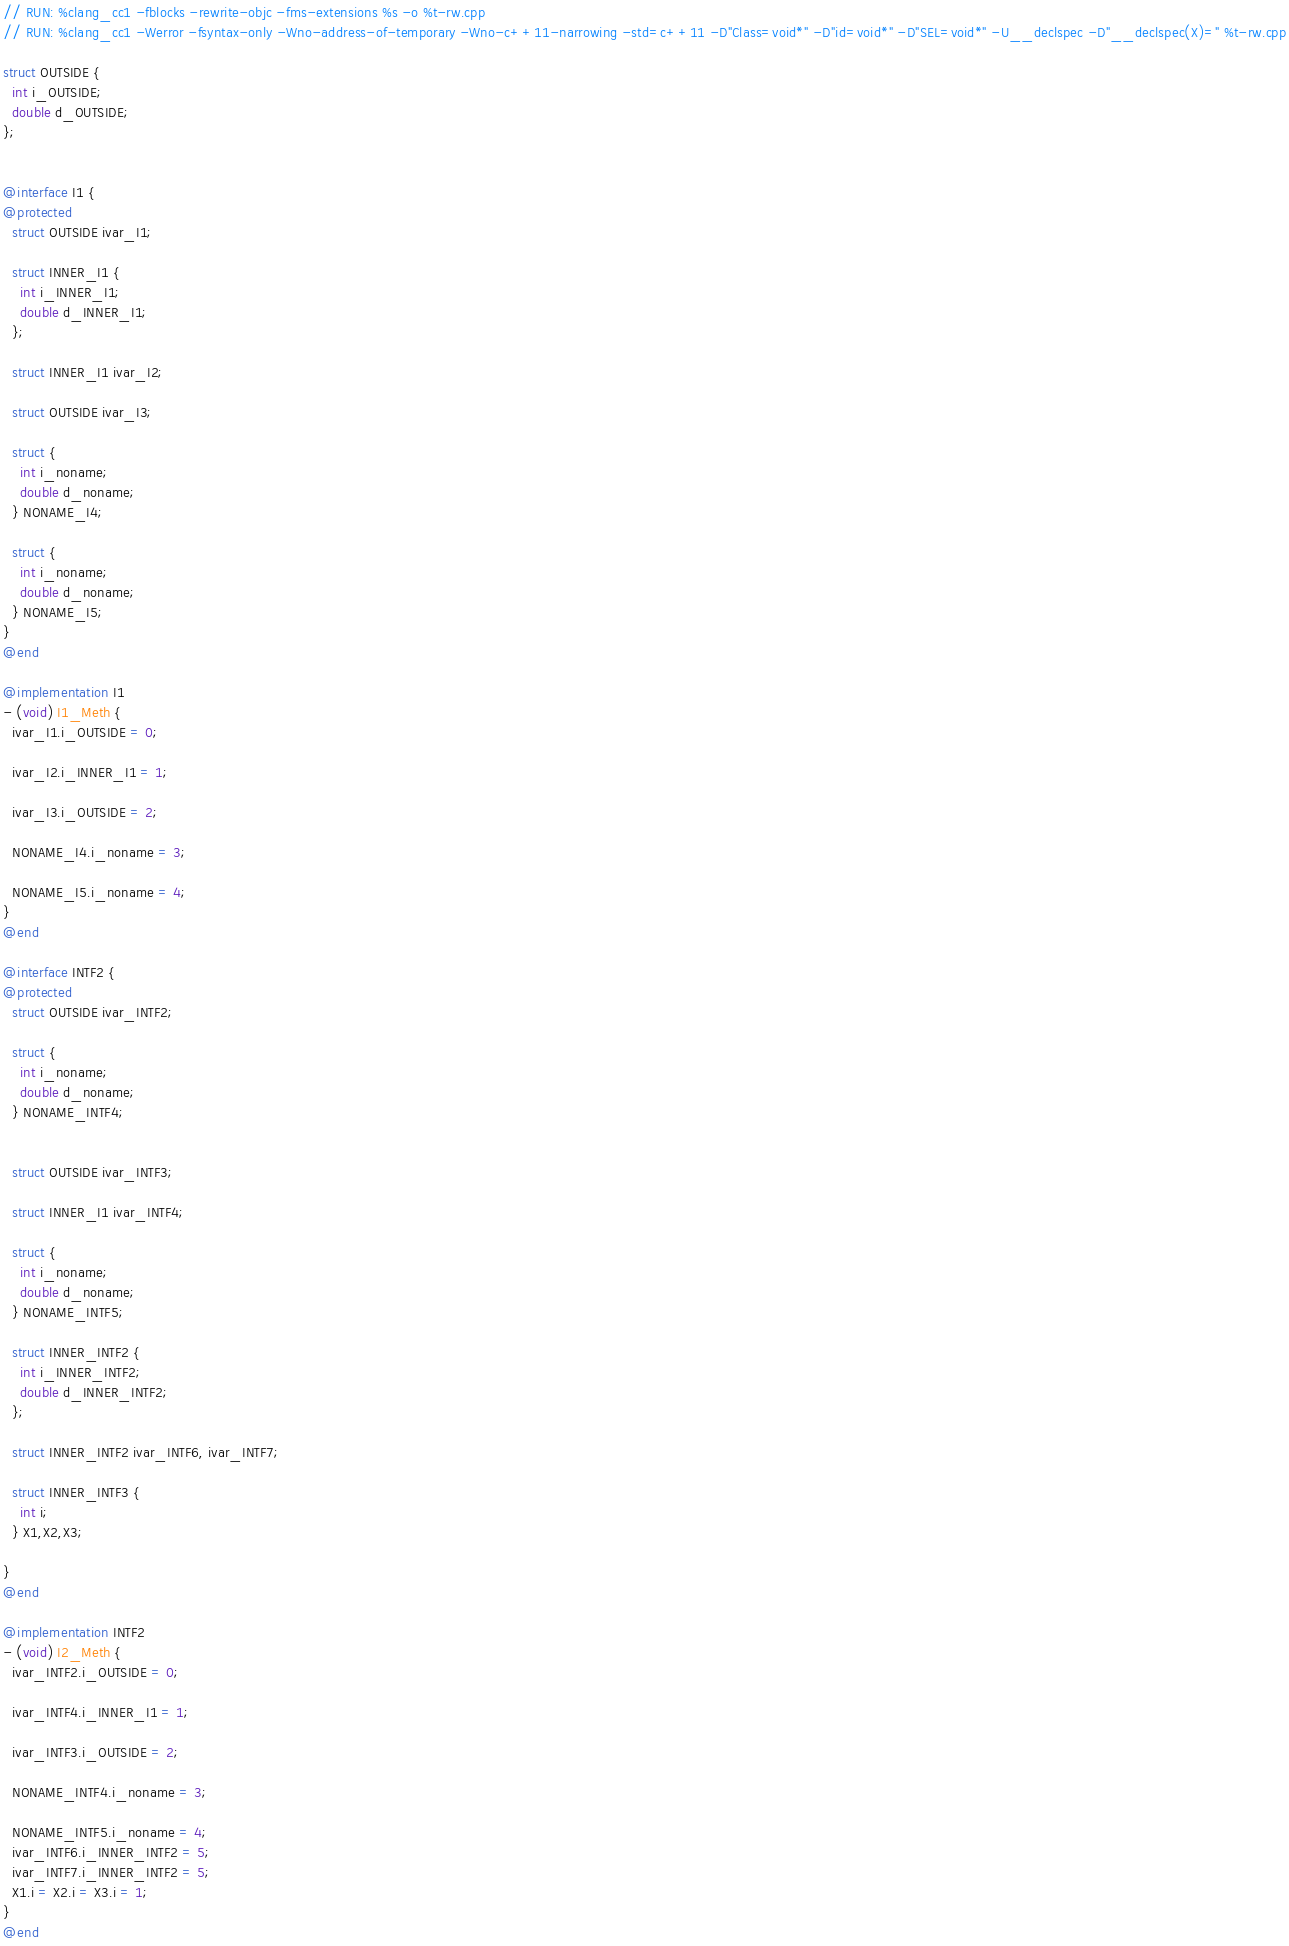Convert code to text. <code><loc_0><loc_0><loc_500><loc_500><_ObjectiveC_>// RUN: %clang_cc1 -fblocks -rewrite-objc -fms-extensions %s -o %t-rw.cpp
// RUN: %clang_cc1 -Werror -fsyntax-only -Wno-address-of-temporary -Wno-c++11-narrowing -std=c++11 -D"Class=void*" -D"id=void*" -D"SEL=void*" -U__declspec -D"__declspec(X)=" %t-rw.cpp

struct OUTSIDE {
  int i_OUTSIDE;
  double d_OUTSIDE;
};


@interface I1 {
@protected
  struct OUTSIDE ivar_I1;

  struct INNER_I1 {
    int i_INNER_I1;
    double d_INNER_I1;
  };

  struct INNER_I1 ivar_I2;

  struct OUTSIDE ivar_I3;

  struct {
    int i_noname;
    double d_noname;
  } NONAME_I4;

  struct {
    int i_noname;
    double d_noname;
  } NONAME_I5;
}
@end

@implementation I1
- (void) I1_Meth {
  ivar_I1.i_OUTSIDE = 0;

  ivar_I2.i_INNER_I1 = 1;

  ivar_I3.i_OUTSIDE = 2;

  NONAME_I4.i_noname = 3;

  NONAME_I5.i_noname = 4;
}
@end

@interface INTF2 {
@protected
  struct OUTSIDE ivar_INTF2;

  struct {
    int i_noname;
    double d_noname;
  } NONAME_INTF4;


  struct OUTSIDE ivar_INTF3;

  struct INNER_I1 ivar_INTF4;

  struct {
    int i_noname;
    double d_noname;
  } NONAME_INTF5;

  struct INNER_INTF2 {
    int i_INNER_INTF2;
    double d_INNER_INTF2;
  };

  struct INNER_INTF2 ivar_INTF6, ivar_INTF7;

  struct INNER_INTF3 {
    int i;
  } X1,X2,X3;

}
@end

@implementation INTF2
- (void) I2_Meth {
  ivar_INTF2.i_OUTSIDE = 0;

  ivar_INTF4.i_INNER_I1 = 1;

  ivar_INTF3.i_OUTSIDE = 2;

  NONAME_INTF4.i_noname = 3;

  NONAME_INTF5.i_noname = 4;
  ivar_INTF6.i_INNER_INTF2 = 5;
  ivar_INTF7.i_INNER_INTF2 = 5;
  X1.i = X2.i = X3.i = 1;
}
@end

</code> 